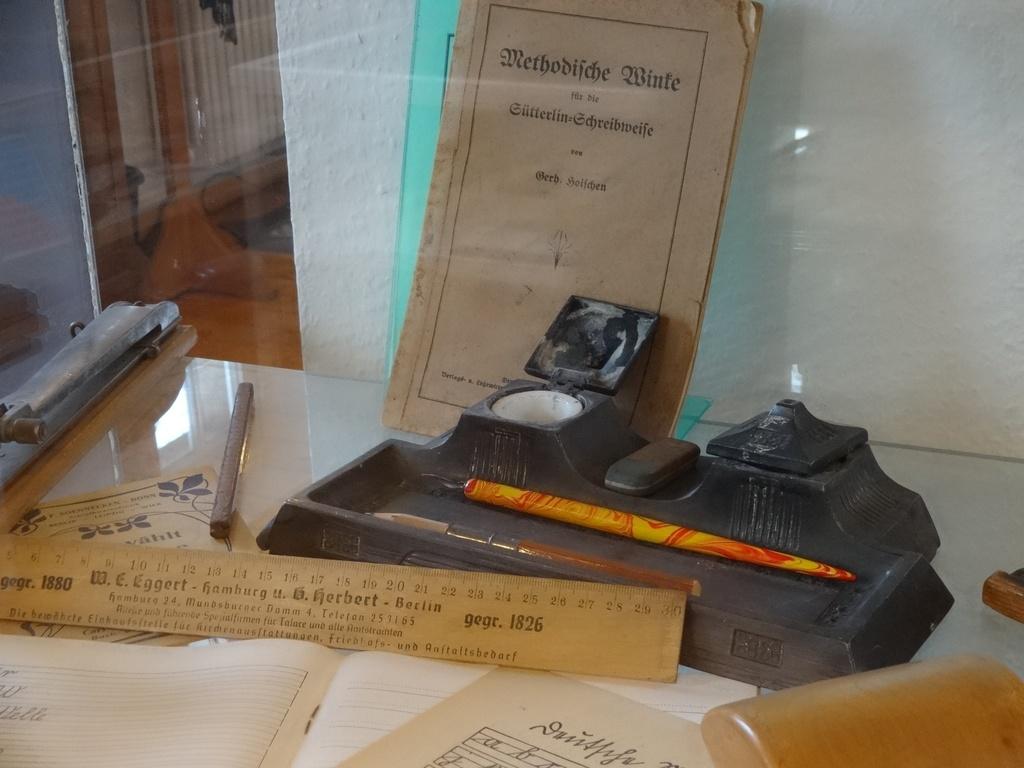How many inches is the ruler ?
Offer a terse response. 30. 